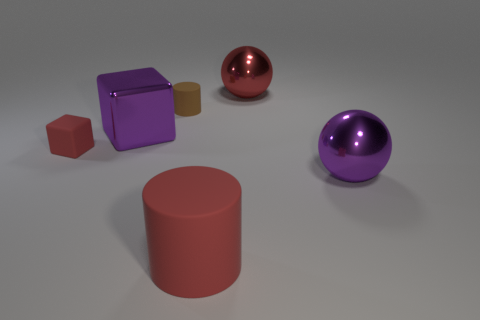Subtract all red cylinders. How many cylinders are left? 1 Add 1 tiny cubes. How many objects exist? 7 Subtract 1 balls. How many balls are left? 1 Subtract all tiny gray rubber spheres. Subtract all metal objects. How many objects are left? 3 Add 2 big red cylinders. How many big red cylinders are left? 3 Add 2 tiny green blocks. How many tiny green blocks exist? 2 Subtract 0 blue cylinders. How many objects are left? 6 Subtract all red cylinders. Subtract all brown cubes. How many cylinders are left? 1 